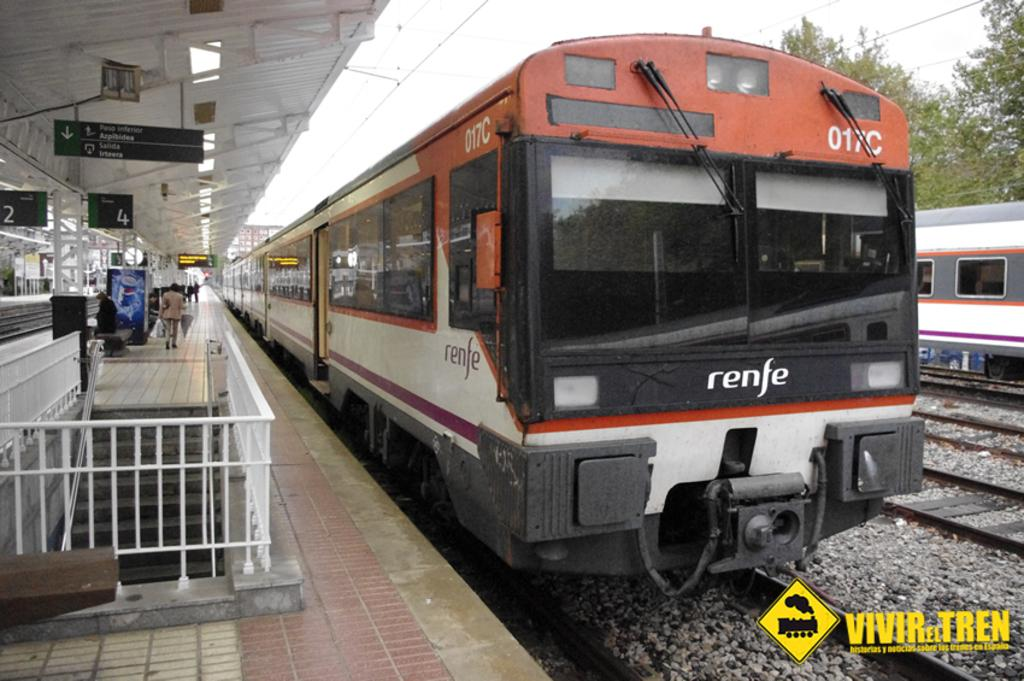Provide a one-sentence caption for the provided image. A railway station has a renfe train sitting on the tracks. 